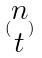Convert formula to latex. <formula><loc_0><loc_0><loc_500><loc_500>( \begin{matrix} n \\ t \end{matrix} )</formula> 